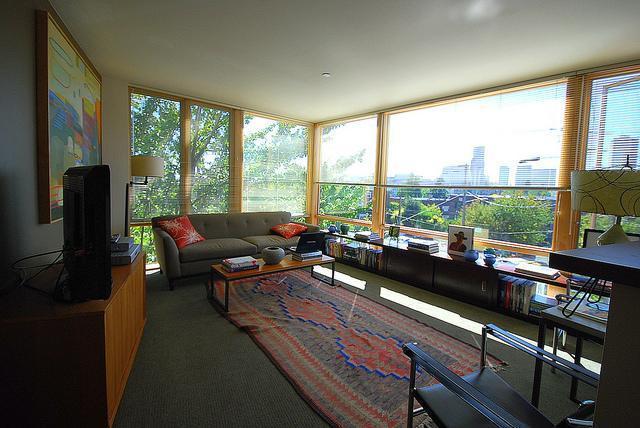How many windows are there?
Give a very brief answer. 6. 